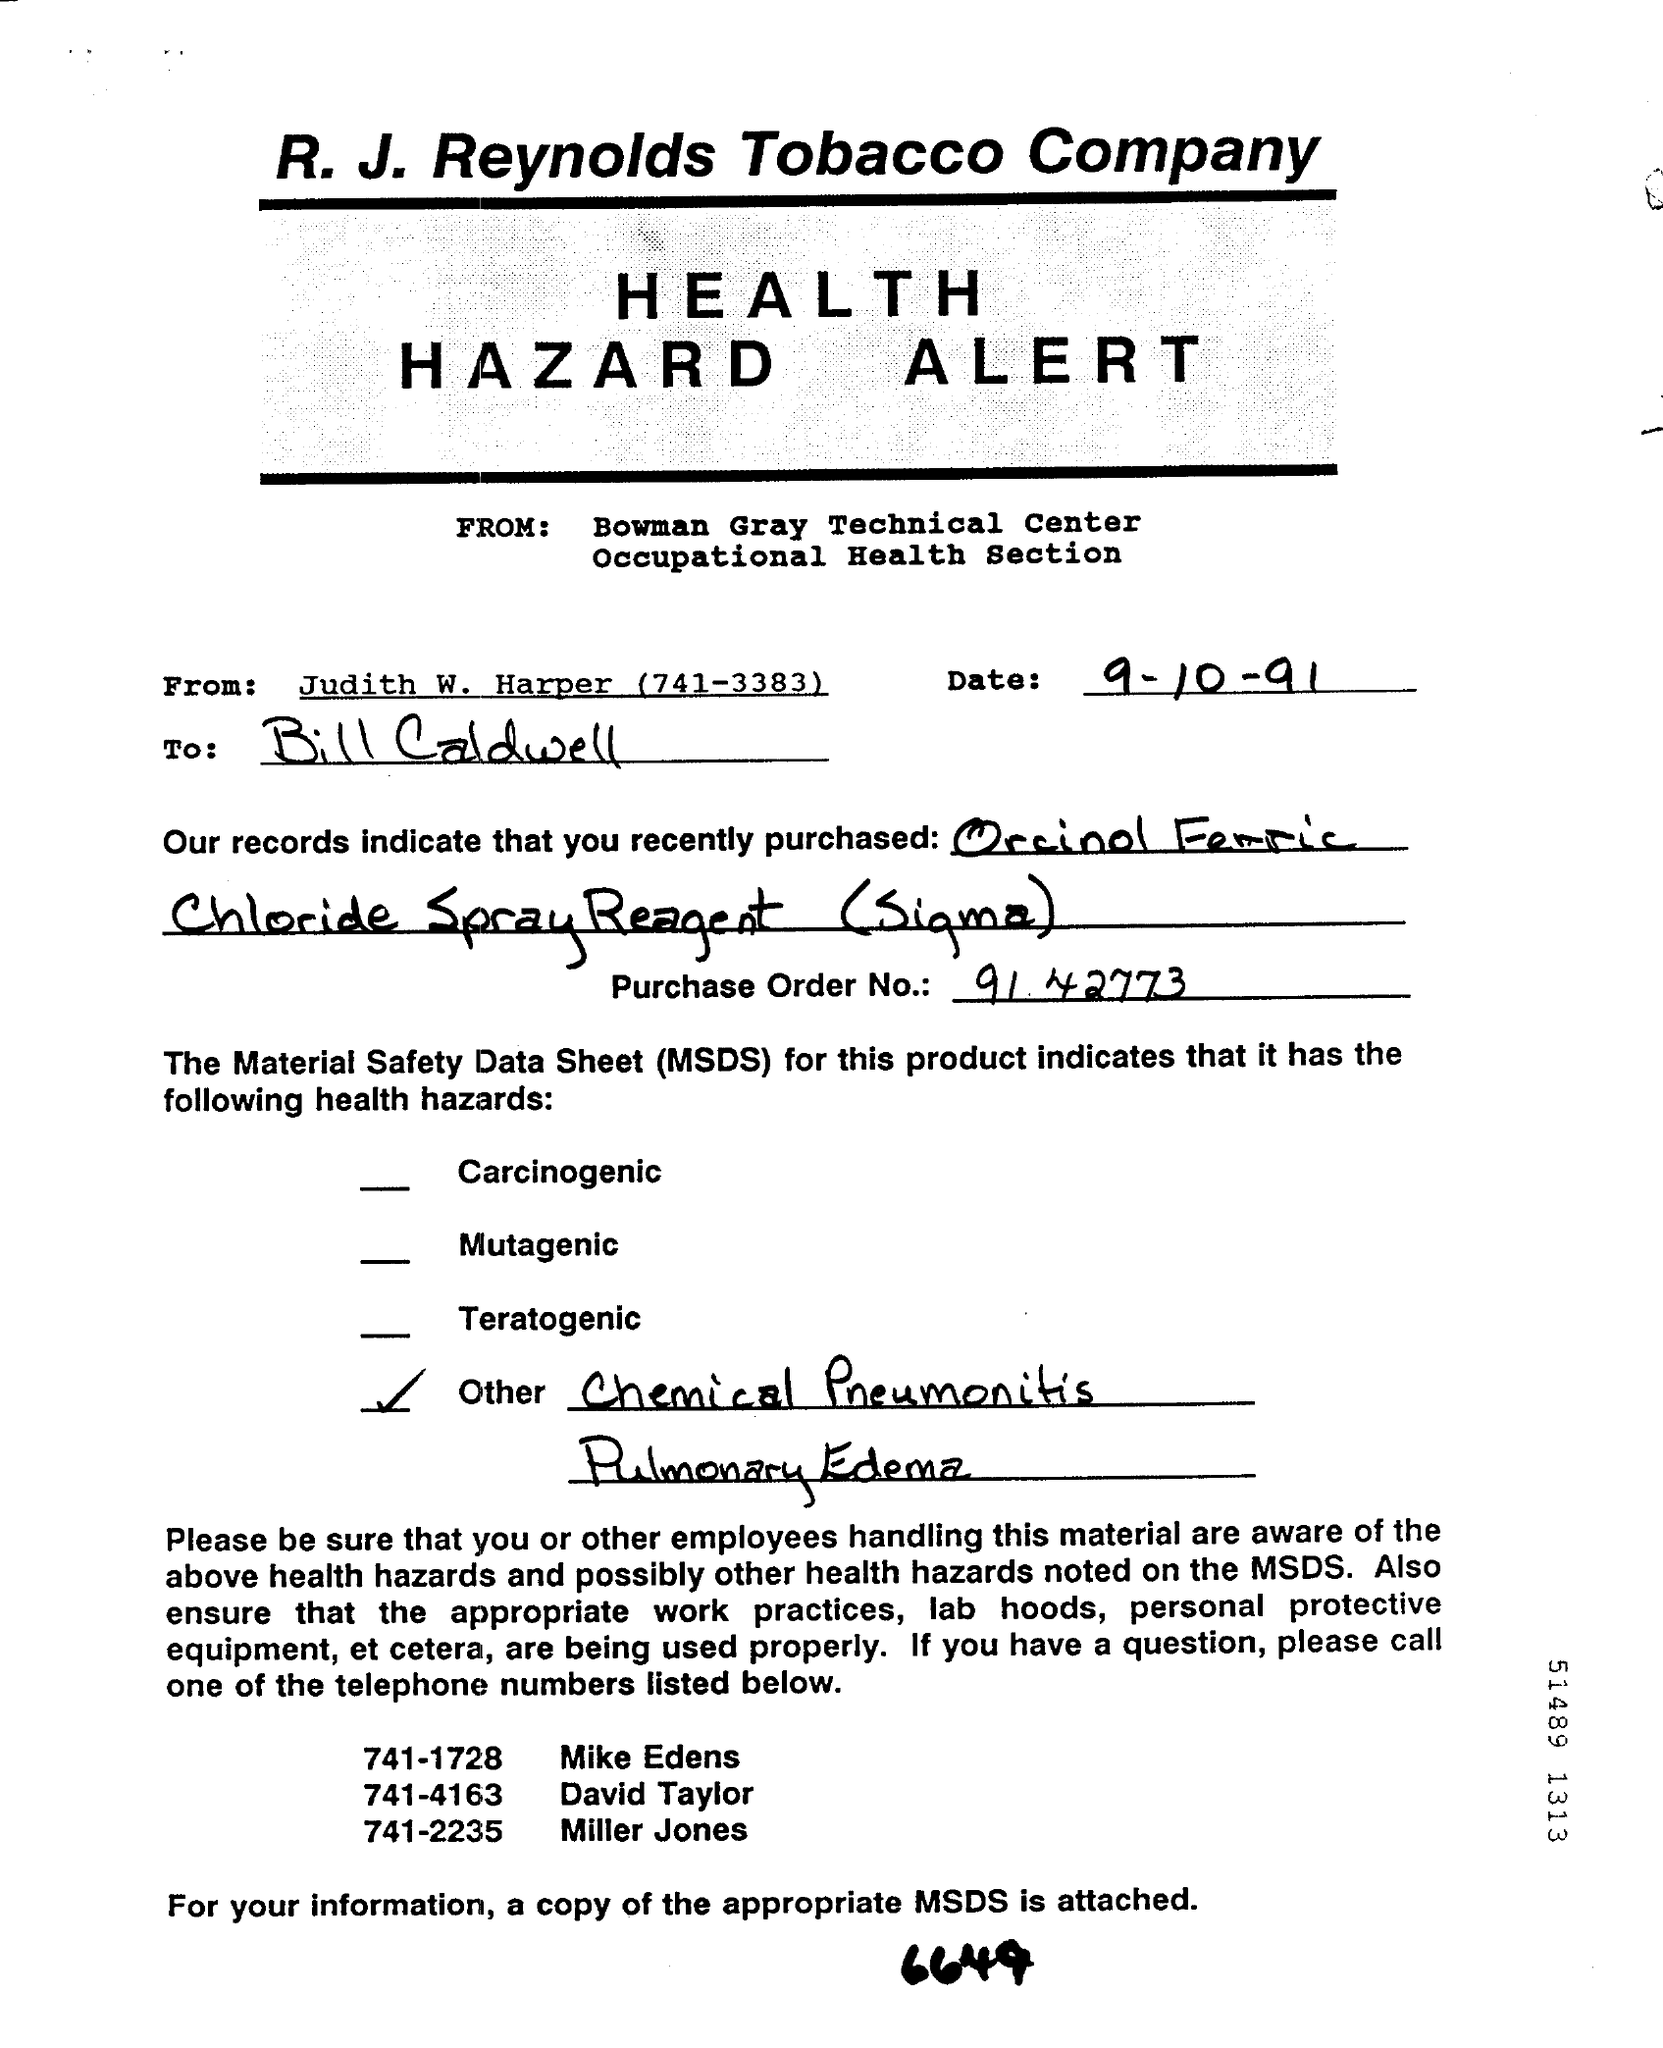Draw attention to some important aspects in this diagram. The telephone number of Miller Jones is 741-2235. The telephone number of David Taylor is 741-4163. The abbreviation "MSDS" stands for "Material Safety Data Sheet. The telephone number of Judith W. Harper is 741-3383. The date mentioned is September 10, 1991. 